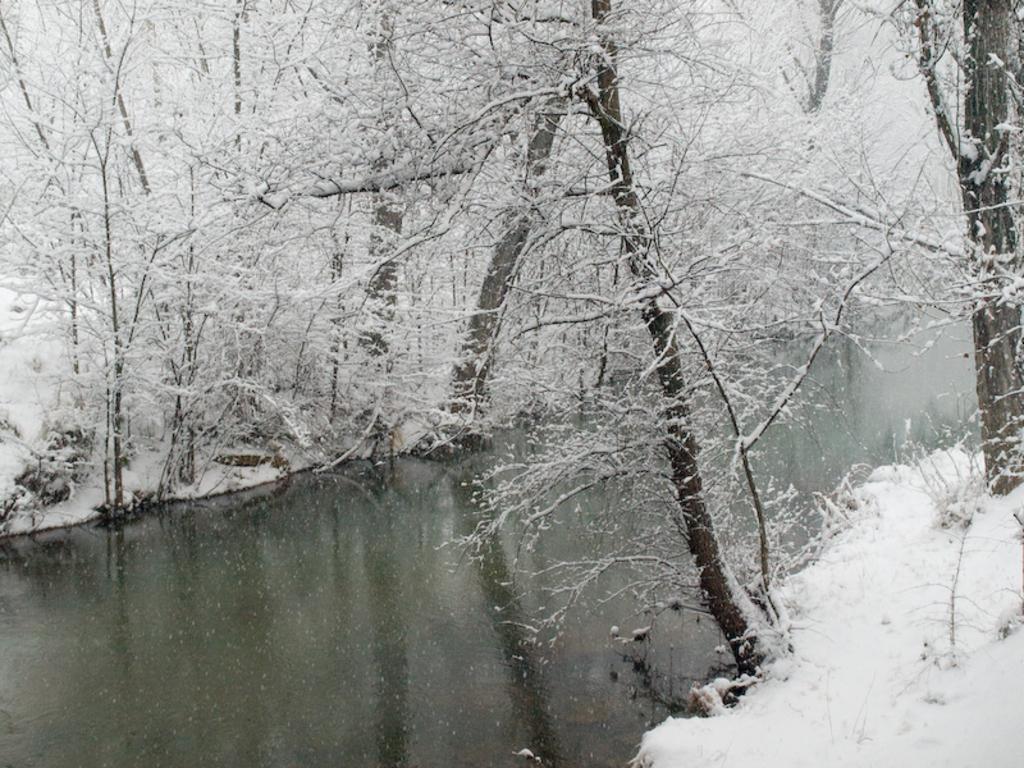Please provide a concise description of this image. In this picture we can see water, few trees and snow. 